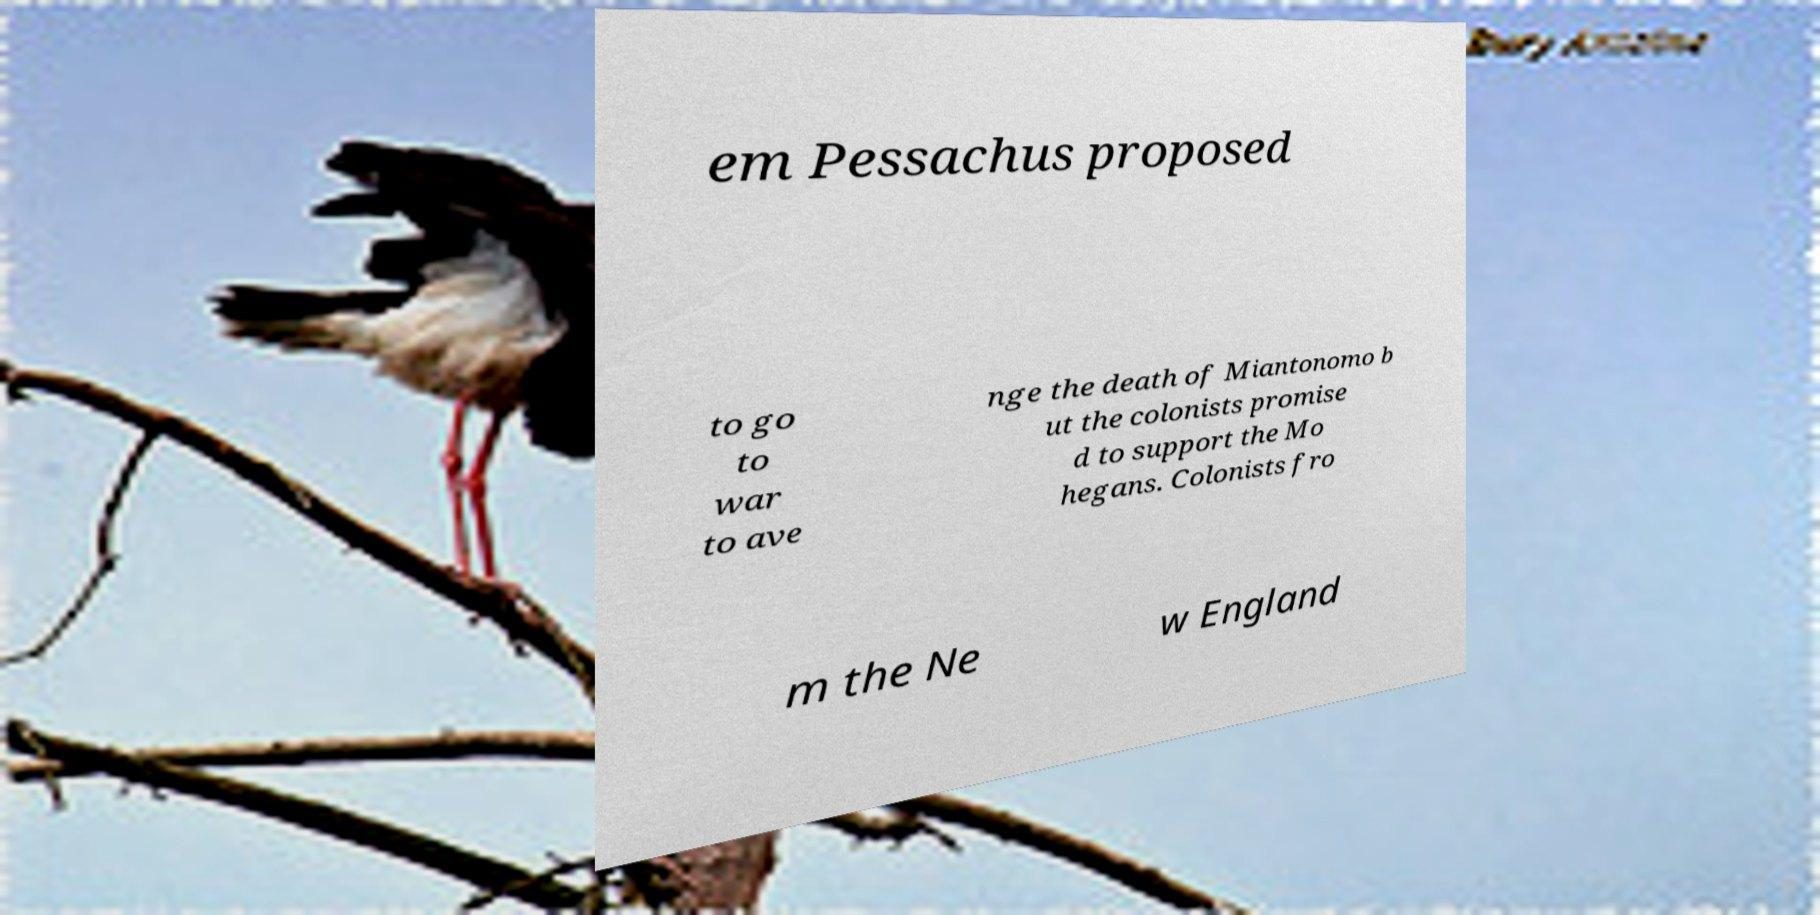Could you extract and type out the text from this image? em Pessachus proposed to go to war to ave nge the death of Miantonomo b ut the colonists promise d to support the Mo hegans. Colonists fro m the Ne w England 